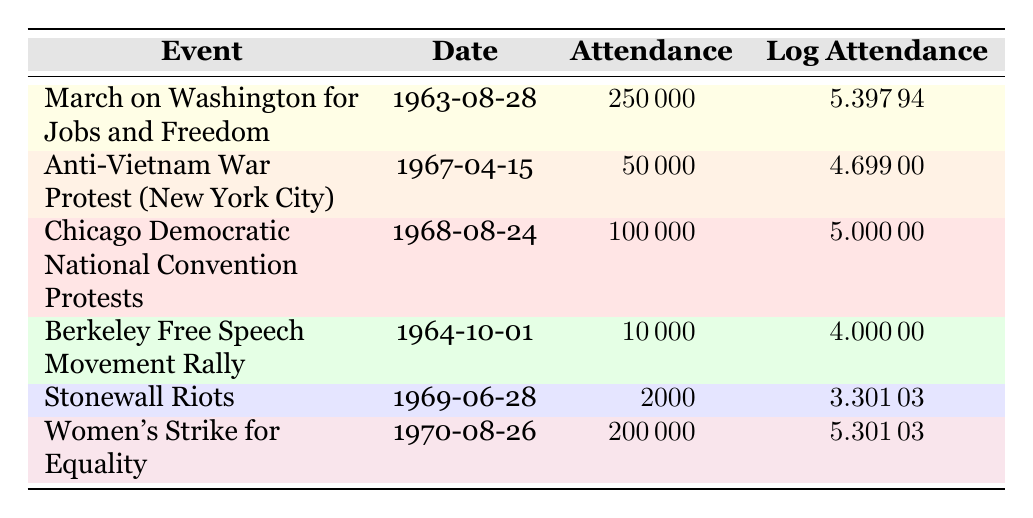What was the attendance of the March on Washington for Jobs and Freedom? The table lists the attendance for each event, where the March on Washington for Jobs and Freedom has an attendance figure of 250,000.
Answer: 250,000 Which event had the lowest attendance? By looking at the attendance figures in the table, the Stonewall Riots had the lowest attendance at 2,000.
Answer: 2,000 What is the difference in attendance between the Chicago Democratic National Convention Protests and the Anti-Vietnam War Protest? The table shows that the attendance for the Chicago Democratic National Convention Protests is 100,000 and for the Anti-Vietnam War Protest is 50,000. The difference is calculated as 100,000 - 50,000 = 50,000.
Answer: 50,000 How many events had an attendance greater than 100,000? In the table, there are two events with an attendance greater than 100,000: the March on Washington for Jobs and Freedom (250,000) and the Chicago Democratic National Convention Protests (100,000), totaling two events.
Answer: 2 What is the average attendance for the protests listed in the table? To find the average attendance, sum the attendance figures (250,000 + 50,000 + 100,000 + 10,000 + 2,000 + 200,000 = 612,000). Then divide by the number of events (6), giving an average of 612,000 / 6 = 102,000.
Answer: 102,000 Is the log attendance for the Women's Strike for Equality greater than 5? The table indicates that the log attendance for the Women's Strike for Equality is 5.30103, which is indeed greater than 5.
Answer: Yes Did the Berkeley Free Speech Movement Rally have an attendance of over 20,000? The table shows that the attendance for the Berkeley Free Speech Movement Rally is 10,000, which is less than 20,000.
Answer: No Which event had an attendance closest to 100,000? The events listed were 250,000 (March on Washington), 50,000 (Anti-Vietnam War), 100,000 (Chicago Democratic National Convention), 10,000 (Berkeley), 2,000 (Stonewall), and 200,000 (Women's Strike). The Chicago Democratic National Convention Protests is exactly 100,000, so it's the closest.
Answer: Chicago Democratic National Convention Protests 